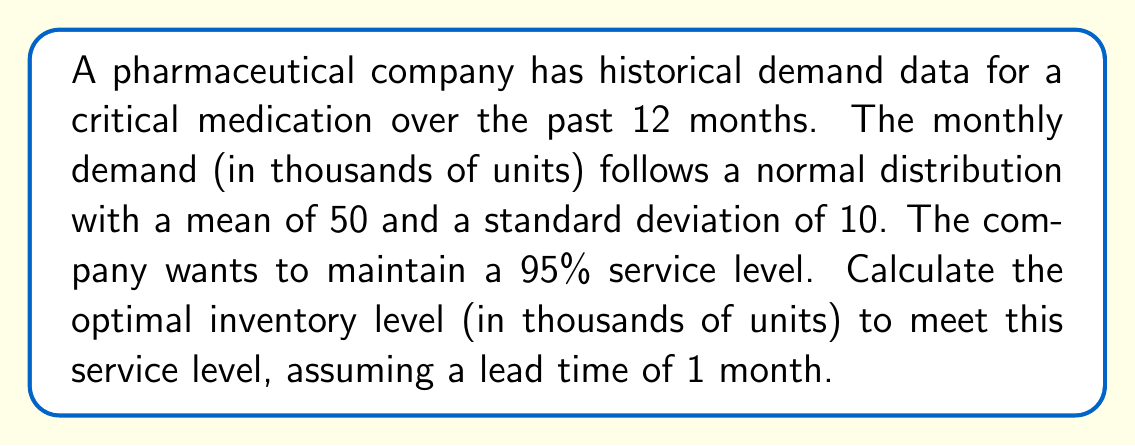Could you help me with this problem? To determine the optimal inventory level, we'll use the concept of safety stock and the inverse normal distribution. Here's the step-by-step process:

1. Identify the given information:
   - Mean demand (μ) = 50,000 units per month
   - Standard deviation of demand (σ) = 10,000 units per month
   - Service level = 95%
   - Lead time (L) = 1 month

2. Calculate the z-score for the 95% service level:
   The z-score for a 95% service level is 1.645 (from the standard normal distribution table).

3. Calculate the safety stock (SS):
   $$ SS = z \cdot \sigma \cdot \sqrt{L} $$
   $$ SS = 1.645 \cdot 10,000 \cdot \sqrt{1} = 16,450 \text{ units} $$

4. Calculate the average demand during lead time (D):
   $$ D = \mu \cdot L $$
   $$ D = 50,000 \cdot 1 = 50,000 \text{ units} $$

5. Calculate the optimal inventory level (OIL):
   $$ OIL = D + SS $$
   $$ OIL = 50,000 + 16,450 = 66,450 \text{ units} $$

6. Convert the result to thousands of units:
   $$ 66,450 \div 1,000 = 66.45 \text{ thousand units} $$

Therefore, the optimal inventory level to maintain a 95% service level is 66.45 thousand units.
Answer: 66.45 